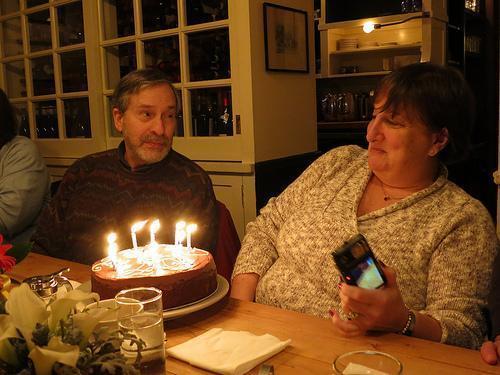How many people are photographed?
Give a very brief answer. 3. 